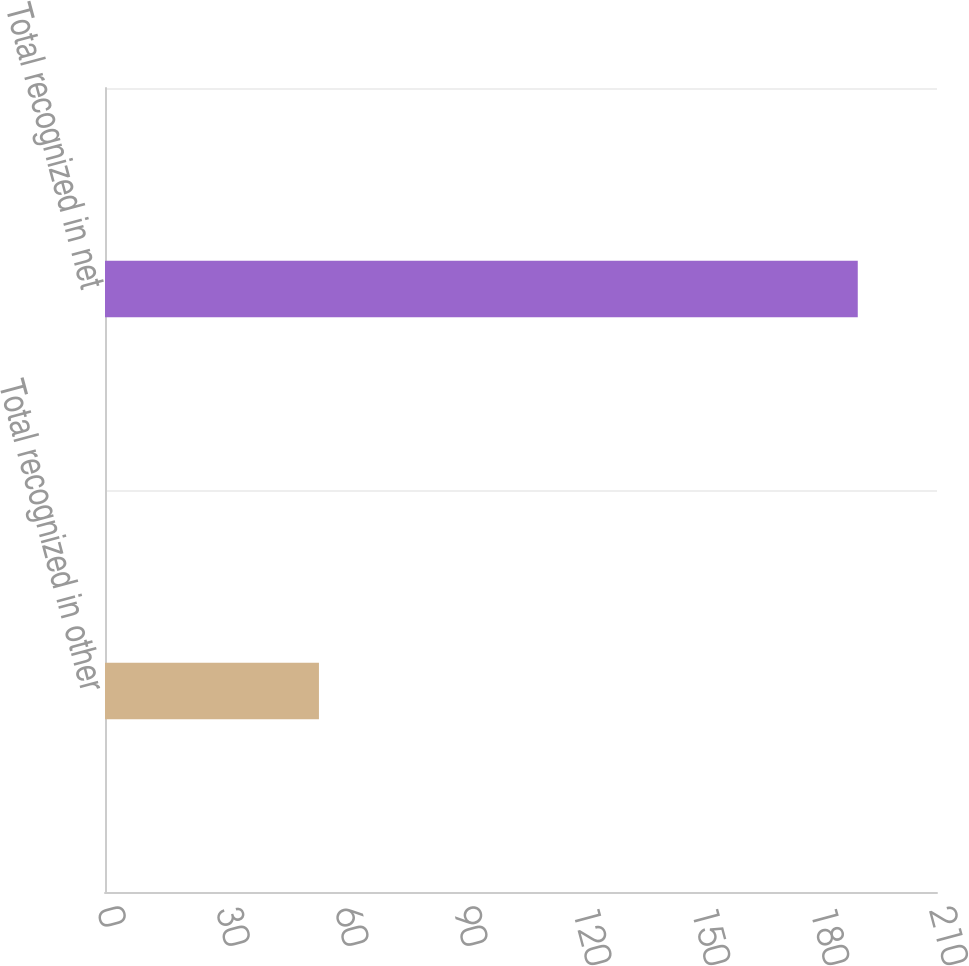Convert chart. <chart><loc_0><loc_0><loc_500><loc_500><bar_chart><fcel>Total recognized in other<fcel>Total recognized in net<nl><fcel>54<fcel>190<nl></chart> 